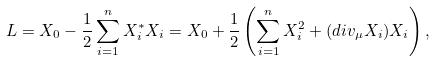Convert formula to latex. <formula><loc_0><loc_0><loc_500><loc_500>L = X _ { 0 } - \frac { 1 } { 2 } \sum _ { i = 1 } ^ { n } X _ { i } ^ { * } X _ { i } = X _ { 0 } + \frac { 1 } { 2 } \left ( \sum _ { i = 1 } ^ { n } X _ { i } ^ { 2 } + ( d i v _ { \mu } X _ { i } ) X _ { i } \right ) ,</formula> 